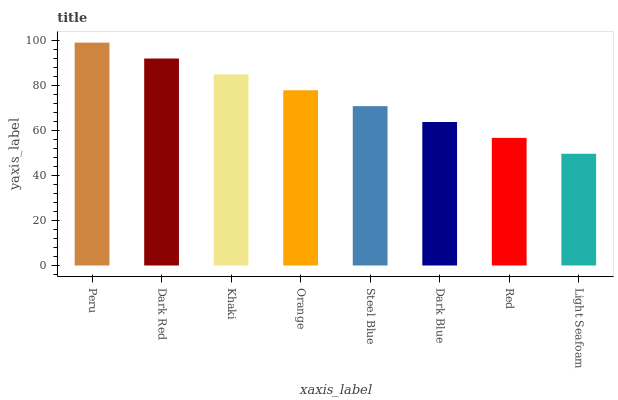Is Dark Red the minimum?
Answer yes or no. No. Is Dark Red the maximum?
Answer yes or no. No. Is Peru greater than Dark Red?
Answer yes or no. Yes. Is Dark Red less than Peru?
Answer yes or no. Yes. Is Dark Red greater than Peru?
Answer yes or no. No. Is Peru less than Dark Red?
Answer yes or no. No. Is Orange the high median?
Answer yes or no. Yes. Is Steel Blue the low median?
Answer yes or no. Yes. Is Dark Blue the high median?
Answer yes or no. No. Is Khaki the low median?
Answer yes or no. No. 